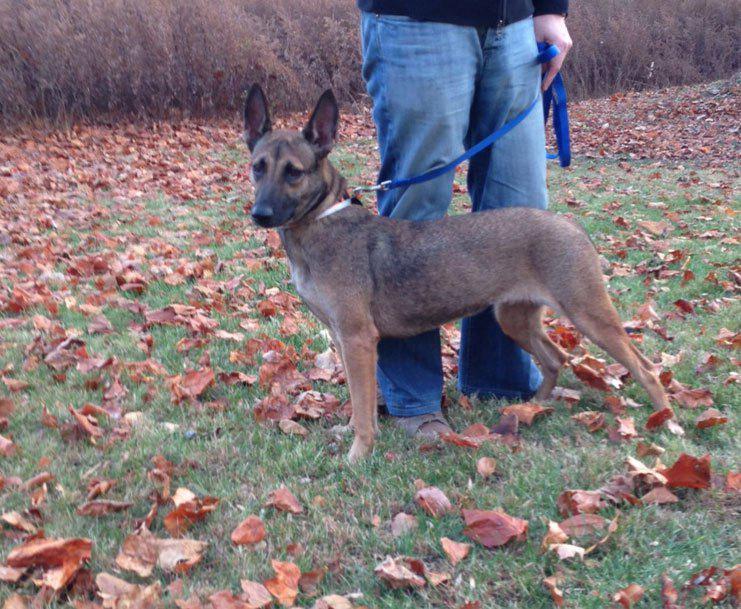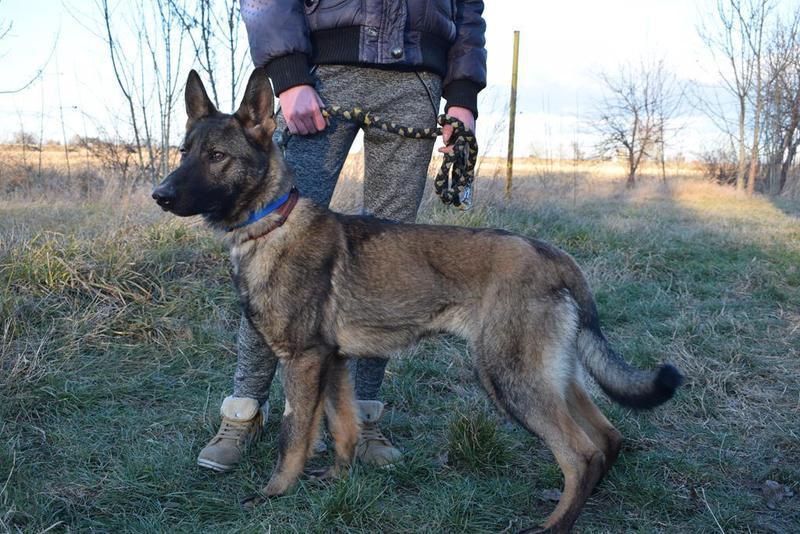The first image is the image on the left, the second image is the image on the right. Considering the images on both sides, is "There are two dogs standing in the grass." valid? Answer yes or no. Yes. The first image is the image on the left, the second image is the image on the right. Examine the images to the left and right. Is the description "There are 2 dogs standing." accurate? Answer yes or no. Yes. 